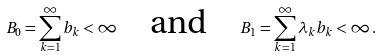Convert formula to latex. <formula><loc_0><loc_0><loc_500><loc_500>B _ { 0 } = \sum ^ { \infty } _ { k = 1 } b _ { k } < \infty \quad \text {and} \quad B _ { 1 } = \sum ^ { \infty } _ { k = 1 } \lambda _ { k } b _ { k } < \infty \, .</formula> 